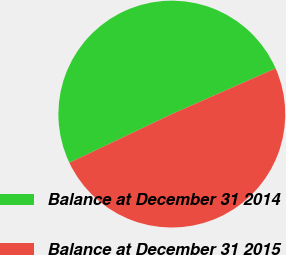Convert chart. <chart><loc_0><loc_0><loc_500><loc_500><pie_chart><fcel>Balance at December 31 2014<fcel>Balance at December 31 2015<nl><fcel>50.46%<fcel>49.54%<nl></chart> 